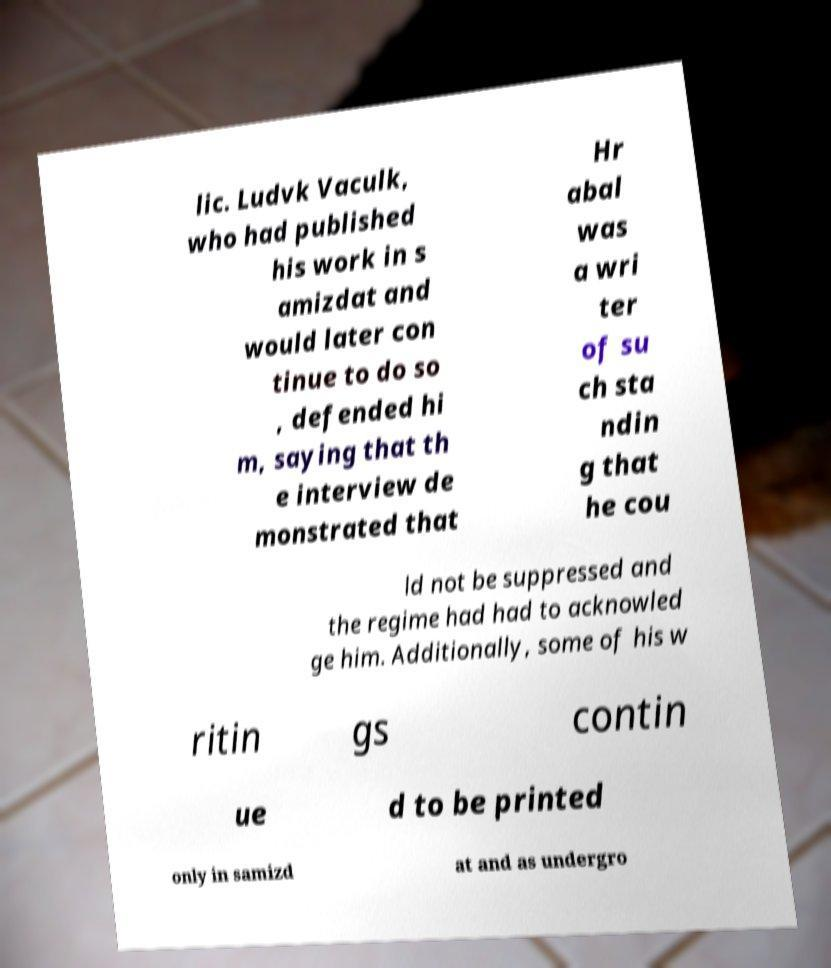What messages or text are displayed in this image? I need them in a readable, typed format. lic. Ludvk Vaculk, who had published his work in s amizdat and would later con tinue to do so , defended hi m, saying that th e interview de monstrated that Hr abal was a wri ter of su ch sta ndin g that he cou ld not be suppressed and the regime had had to acknowled ge him. Additionally, some of his w ritin gs contin ue d to be printed only in samizd at and as undergro 